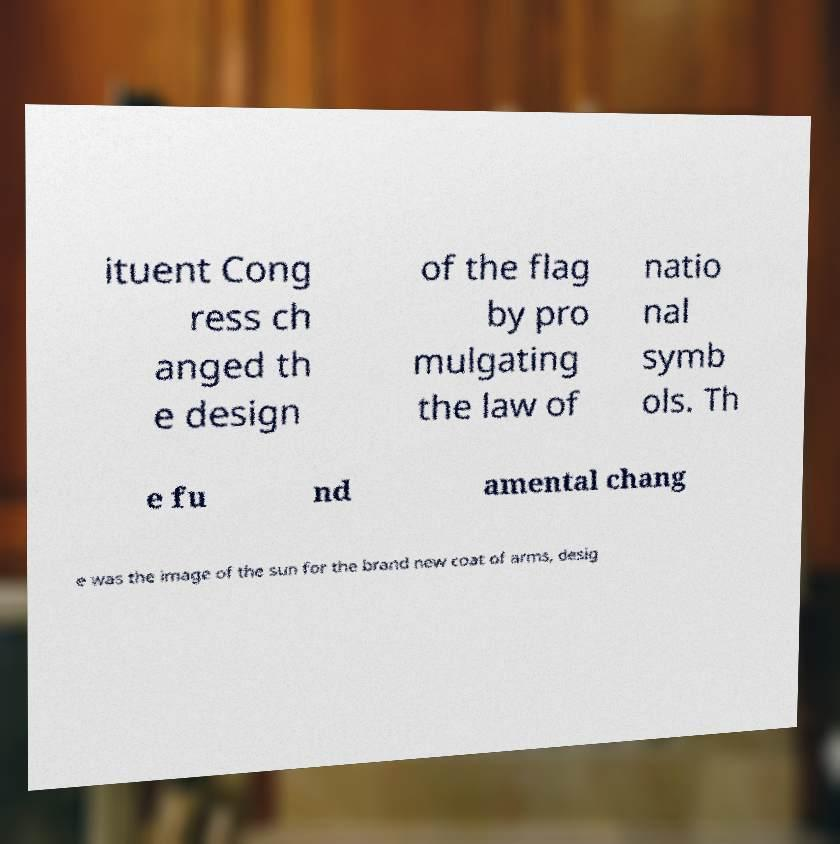There's text embedded in this image that I need extracted. Can you transcribe it verbatim? ituent Cong ress ch anged th e design of the flag by pro mulgating the law of natio nal symb ols. Th e fu nd amental chang e was the image of the sun for the brand new coat of arms, desig 